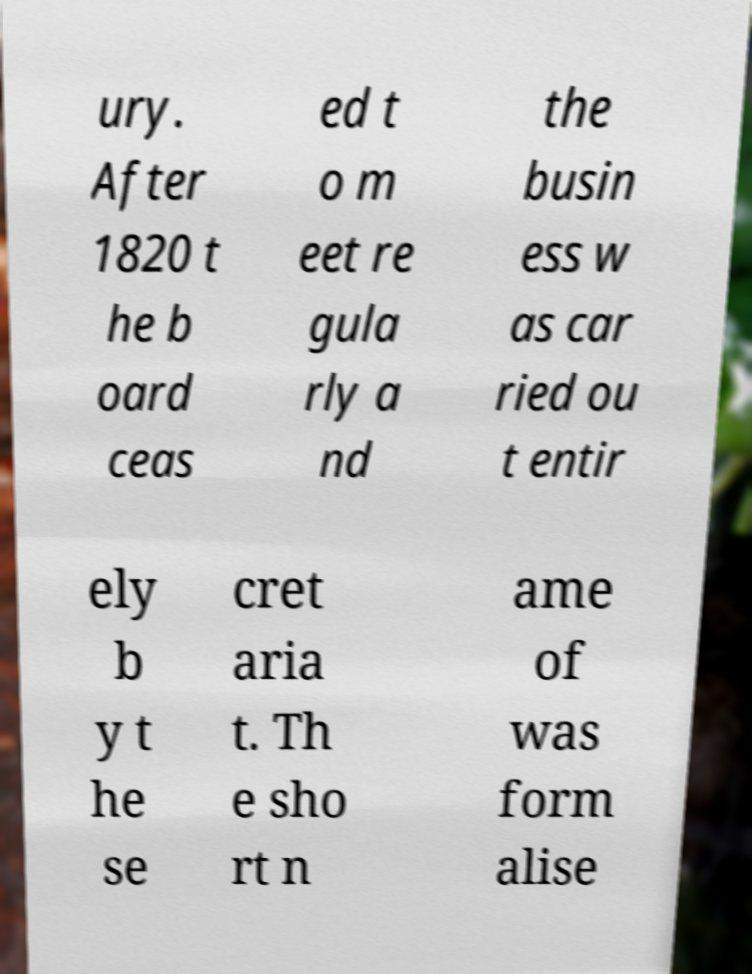Could you extract and type out the text from this image? ury. After 1820 t he b oard ceas ed t o m eet re gula rly a nd the busin ess w as car ried ou t entir ely b y t he se cret aria t. Th e sho rt n ame of was form alise 